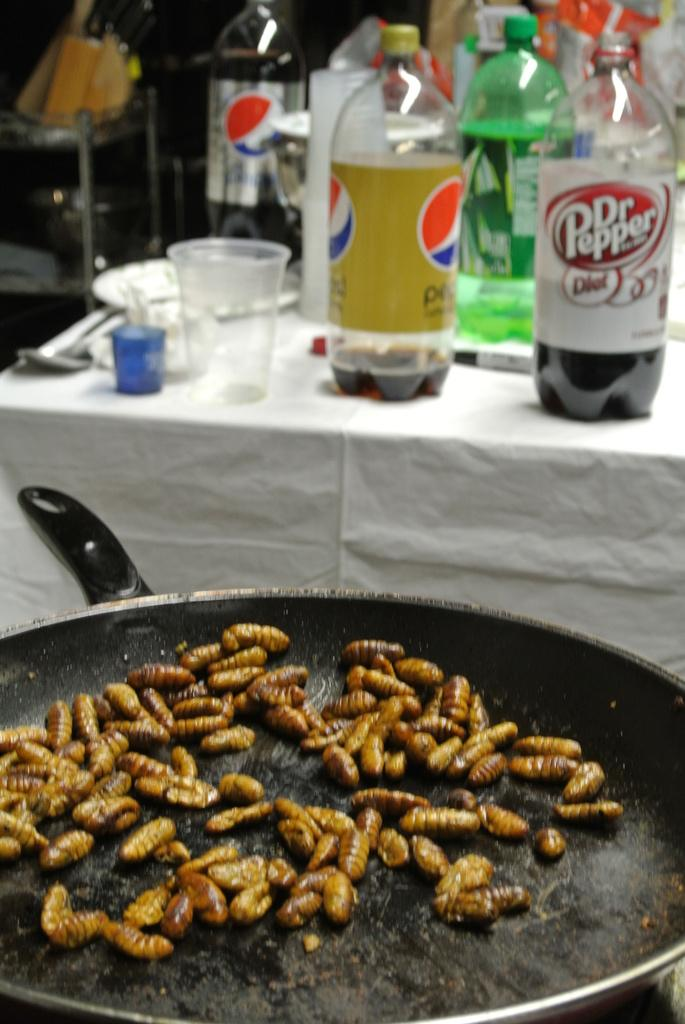<image>
Provide a brief description of the given image. a bottle of Dr Pepper sits in front of a pan of maggots 